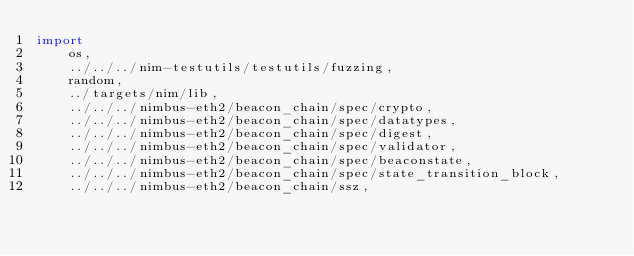<code> <loc_0><loc_0><loc_500><loc_500><_Nim_>import
    os,
    ../../../nim-testutils/testutils/fuzzing,
    random,
    ../targets/nim/lib,
    ../../../nimbus-eth2/beacon_chain/spec/crypto,
    ../../../nimbus-eth2/beacon_chain/spec/datatypes,
    ../../../nimbus-eth2/beacon_chain/spec/digest,
    ../../../nimbus-eth2/beacon_chain/spec/validator,
    ../../../nimbus-eth2/beacon_chain/spec/beaconstate,
    ../../../nimbus-eth2/beacon_chain/spec/state_transition_block,
    ../../../nimbus-eth2/beacon_chain/ssz,</code> 